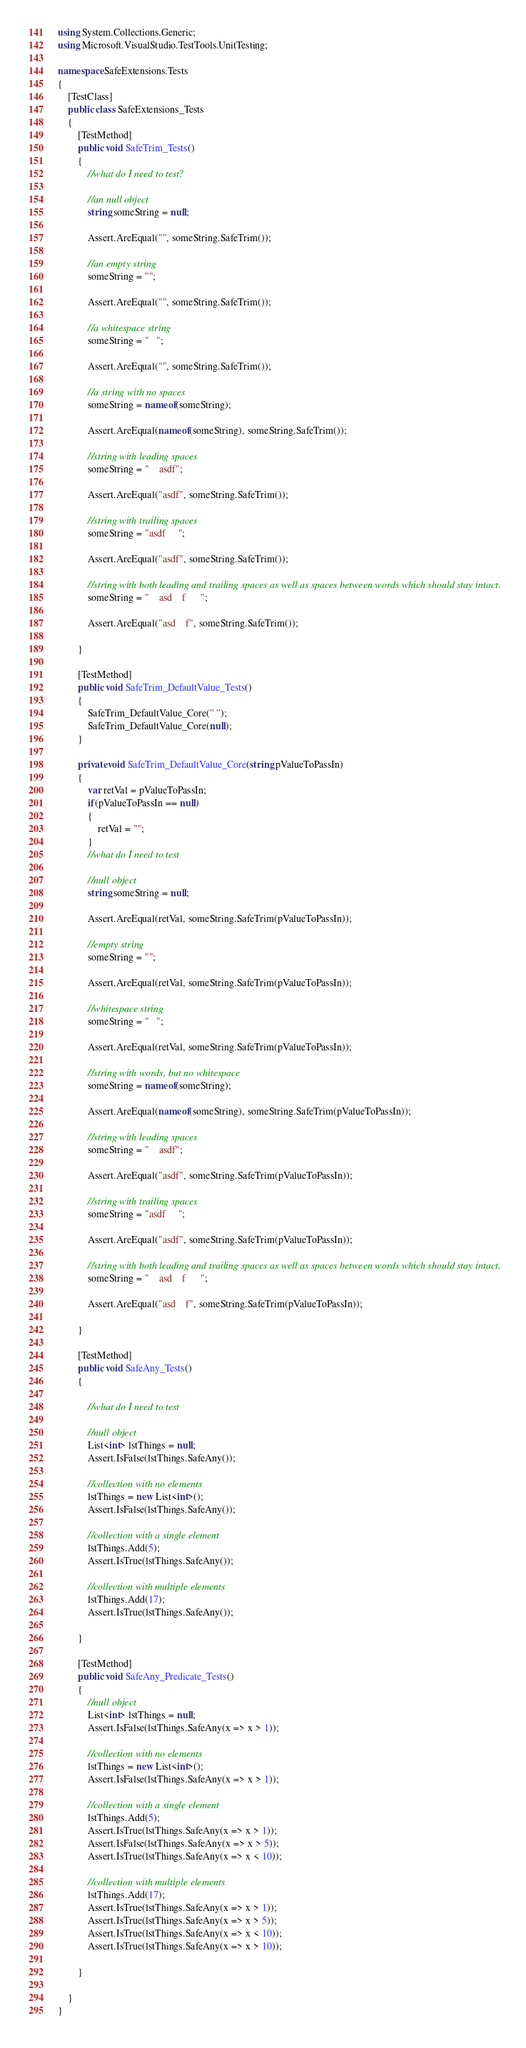Convert code to text. <code><loc_0><loc_0><loc_500><loc_500><_C#_>using System.Collections.Generic;
using Microsoft.VisualStudio.TestTools.UnitTesting;

namespace SafeExtensions.Tests
{
    [TestClass]
    public class SafeExtensions_Tests
    {
        [TestMethod]
        public void SafeTrim_Tests()
        {
            //what do I need to test?

            //an null object
            string someString = null;

            Assert.AreEqual("", someString.SafeTrim());

            //an empty string
            someString = "";

            Assert.AreEqual("", someString.SafeTrim());

            //a whitespace string
            someString = "   ";

            Assert.AreEqual("", someString.SafeTrim());

            //a string with no spaces
            someString = nameof(someString);

            Assert.AreEqual(nameof(someString), someString.SafeTrim());

            //string with leading spaces
            someString = "    asdf";

            Assert.AreEqual("asdf", someString.SafeTrim());

            //string with trailing spaces
            someString = "asdf     ";

            Assert.AreEqual("asdf", someString.SafeTrim());

            //string with both leading and trailing spaces as well as spaces between words which should stay intact.
            someString = "    asd    f      ";

            Assert.AreEqual("asd    f", someString.SafeTrim());

        }

        [TestMethod]
        public void SafeTrim_DefaultValue_Tests()
        {
            SafeTrim_DefaultValue_Core(" ");
            SafeTrim_DefaultValue_Core(null);
        }

        private void SafeTrim_DefaultValue_Core(string pValueToPassIn)
        {
            var retVal = pValueToPassIn;
            if(pValueToPassIn == null)
            {
                retVal = "";
            }
            //what do I need to test

            //null object
            string someString = null;

            Assert.AreEqual(retVal, someString.SafeTrim(pValueToPassIn));

            //empty string
            someString = "";

            Assert.AreEqual(retVal, someString.SafeTrim(pValueToPassIn));

            //whitespace string
            someString = "   ";

            Assert.AreEqual(retVal, someString.SafeTrim(pValueToPassIn));

            //string with words, but no whitespace
            someString = nameof(someString);

            Assert.AreEqual(nameof(someString), someString.SafeTrim(pValueToPassIn));

            //string with leading spaces
            someString = "    asdf";

            Assert.AreEqual("asdf", someString.SafeTrim(pValueToPassIn));

            //string with trailing spaces
            someString = "asdf     ";

            Assert.AreEqual("asdf", someString.SafeTrim(pValueToPassIn));

            //string with both leading and trailing spaces as well as spaces between words which should stay intact.
            someString = "    asd    f      ";

            Assert.AreEqual("asd    f", someString.SafeTrim(pValueToPassIn));

        }

        [TestMethod]
        public void SafeAny_Tests()
        {

            //what do I need to test

            //null object
            List<int> lstThings = null;
            Assert.IsFalse(lstThings.SafeAny());

            //collection with no elements
            lstThings = new List<int>();
            Assert.IsFalse(lstThings.SafeAny());

            //collection with a single element
            lstThings.Add(5);
            Assert.IsTrue(lstThings.SafeAny());

            //collection with multiple elements
            lstThings.Add(17);
            Assert.IsTrue(lstThings.SafeAny());

        }

        [TestMethod]
        public void SafeAny_Predicate_Tests()
        {
            //null object
            List<int> lstThings = null;
            Assert.IsFalse(lstThings.SafeAny(x => x > 1));

            //collection with no elements
            lstThings = new List<int>();
            Assert.IsFalse(lstThings.SafeAny(x => x > 1));

            //collection with a single element
            lstThings.Add(5);
            Assert.IsTrue(lstThings.SafeAny(x => x > 1));
            Assert.IsFalse(lstThings.SafeAny(x => x > 5));
            Assert.IsTrue(lstThings.SafeAny(x => x < 10));

            //collection with multiple elements
            lstThings.Add(17);
            Assert.IsTrue(lstThings.SafeAny(x => x > 1));
            Assert.IsTrue(lstThings.SafeAny(x => x > 5));
            Assert.IsTrue(lstThings.SafeAny(x => x < 10));
            Assert.IsTrue(lstThings.SafeAny(x => x > 10));

        }

    }
}
</code> 